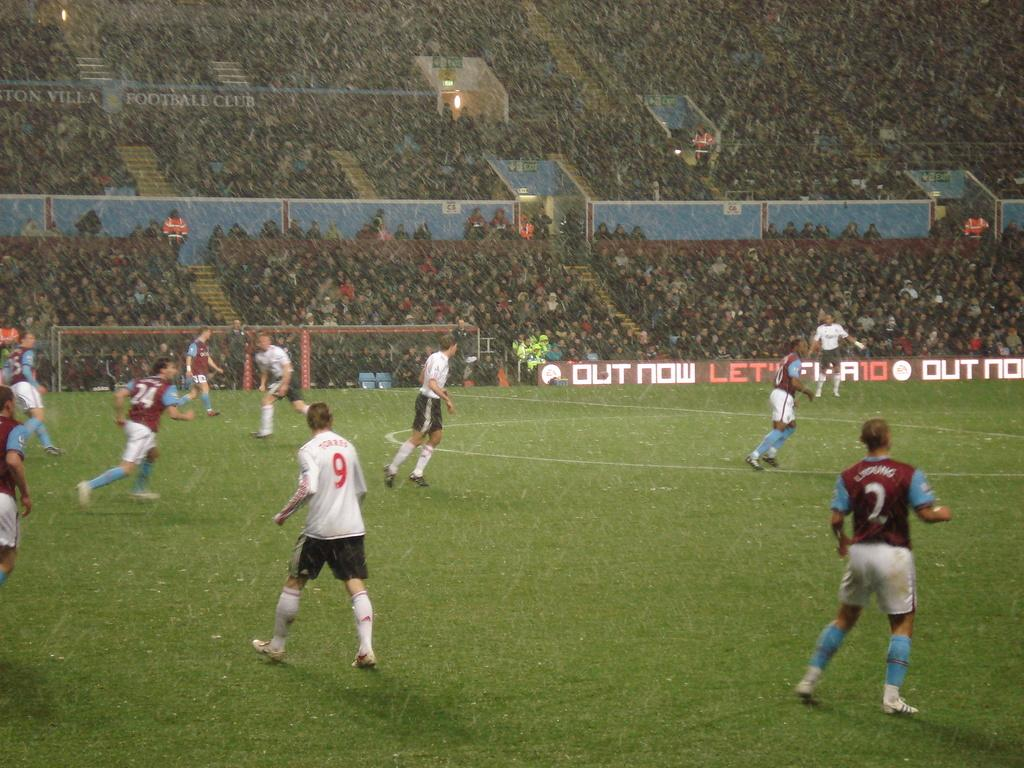Provide a one-sentence caption for the provided image. A soccer field with players 9 and 2 standing toward the camera. 